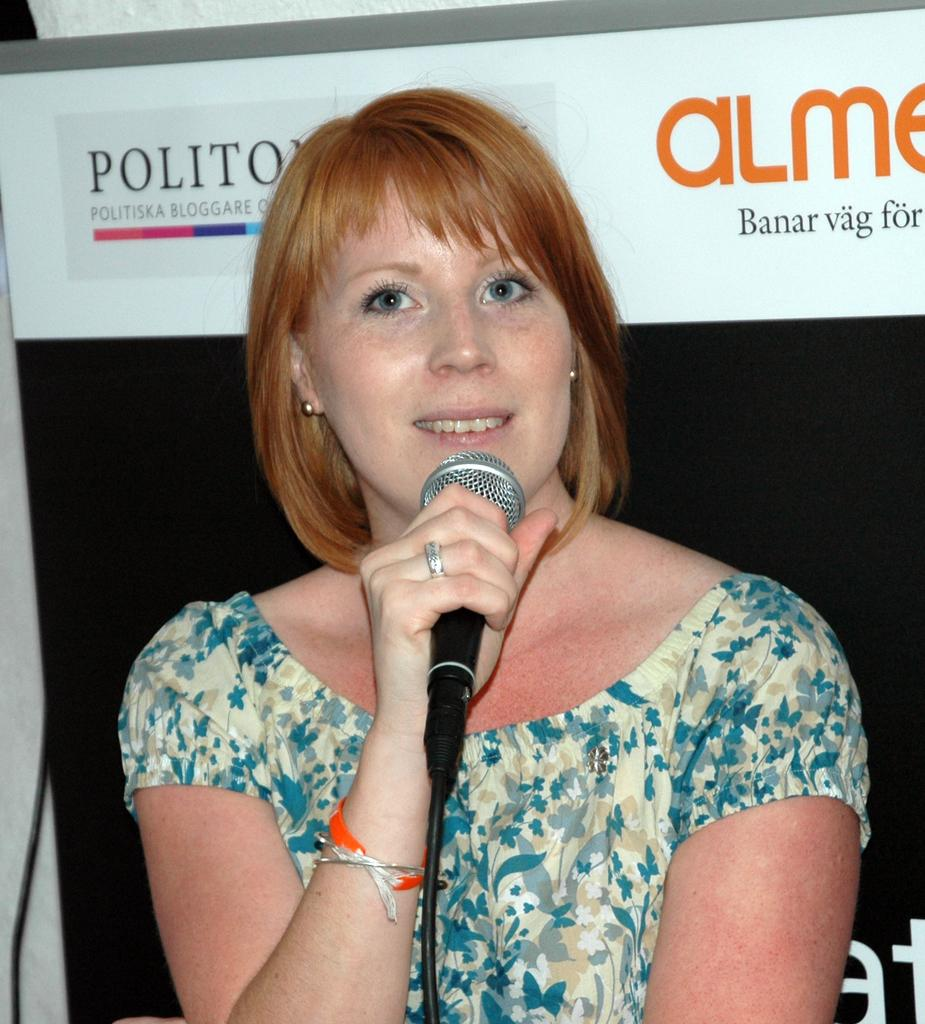What is the main subject of the image? The main subject of the image is a woman. What is the woman holding in the image? The woman is holding a mic. How many kittens are playing with the brick in the image? There are no kittens or bricks present in the image. What type of battle is taking place in the image? There is no battle depicted in the image; it features a woman holding a mic. 